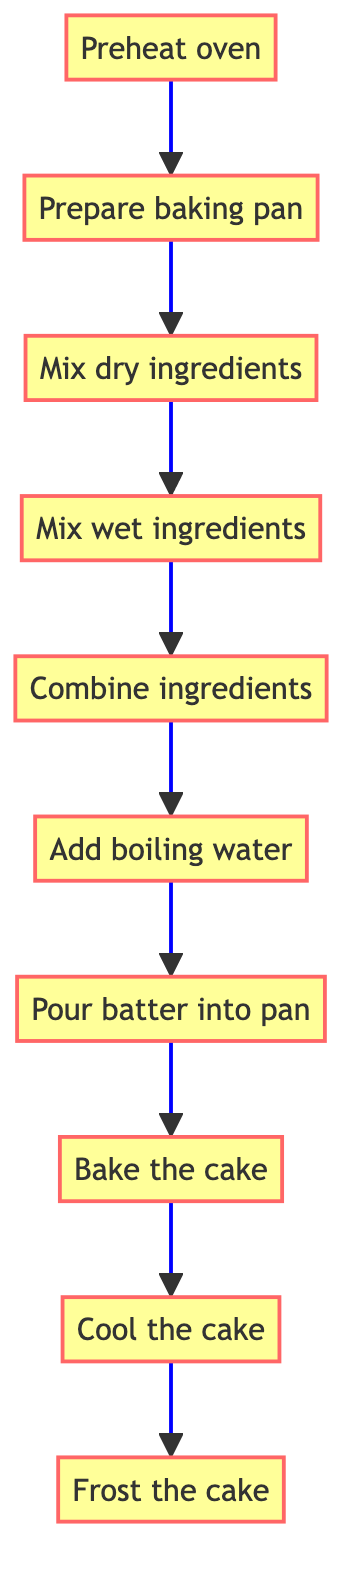What is the first step in the baking process? The first step is indicated by the starting node in the flow chart, which shows "Preheat oven" as the initial action.
Answer: Preheat oven How many steps are there in total to bake the chocolate cake? By counting all the distinct nodes in the flow chart, there are ten steps listed from "Preheat oven" to "Frost the cake".
Answer: 10 What is the last step of the chocolate cake baking process? The last step in the flow chart is shown as "Frost the cake", which comes after all other steps have been completed.
Answer: Frost the cake Which step comes right after "Mix dry ingredients"? In the flow chart, "Mix wet ingredients" directly follows the "Mix dry ingredients" step, indicating the order of actions.
Answer: Mix wet ingredients What do you do immediately after "Bake the cake"? After completing the "Bake the cake" step, the next instruction in the flow chart is to "Cool the cake".
Answer: Cool the cake What is the relationship between "Combine ingredients" and "Add boiling water"? The flow chart illustrates a direct connection from "Combine ingredients" to "Add boiling water", indicating that you must add boiling water after combining the ingredients.
Answer: Direct connection Which two steps are connected by a single arrow? The flow chart shows a one-way connection with a single arrow from "Prepare baking pan" to "Mix dry ingredients", indicating sequential actions.
Answer: Prepare baking pan and Mix dry ingredients Which step requires the use of boiling water? The flow chart specifies "Add boiling water" as a step that directly mentions using boiling water in the preparation of the cake.
Answer: Add boiling water What should you do before pouring batter into the pan? According to the flow chart, "Prepare baking pan" must be completed before the step "Pour batter into pan" can take place.
Answer: Prepare baking pan In which step are eggs mixed? The step "Mix wet ingredients" includes the mixing of two large eggs, thus answering the question regarding where eggs are incorporated.
Answer: Mix wet ingredients 